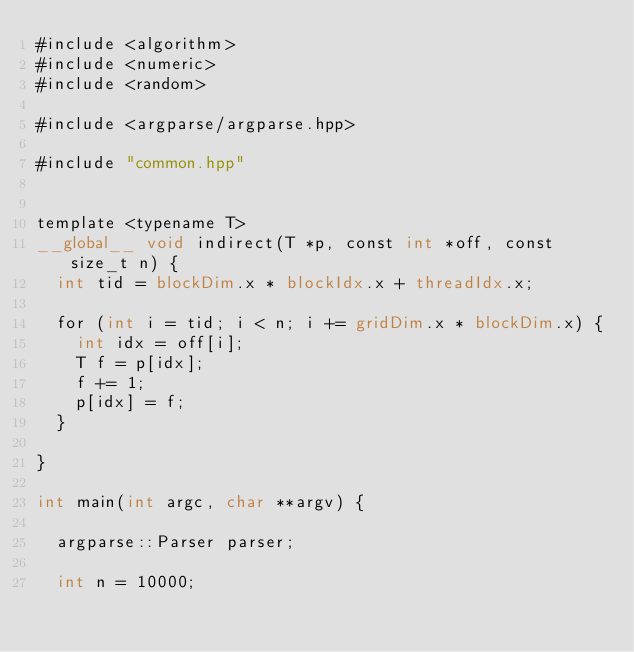Convert code to text. <code><loc_0><loc_0><loc_500><loc_500><_Cuda_>#include <algorithm>
#include <numeric>
#include <random>

#include <argparse/argparse.hpp>

#include "common.hpp"


template <typename T>
__global__ void indirect(T *p, const int *off, const size_t n) {
  int tid = blockDim.x * blockIdx.x + threadIdx.x;

  for (int i = tid; i < n; i += gridDim.x * blockDim.x) {
    int idx = off[i];
    T f = p[idx];
    f += 1;
    p[idx] = f;
  }

}

int main(int argc, char **argv) {

  argparse::Parser parser;

  int n = 10000;</code> 